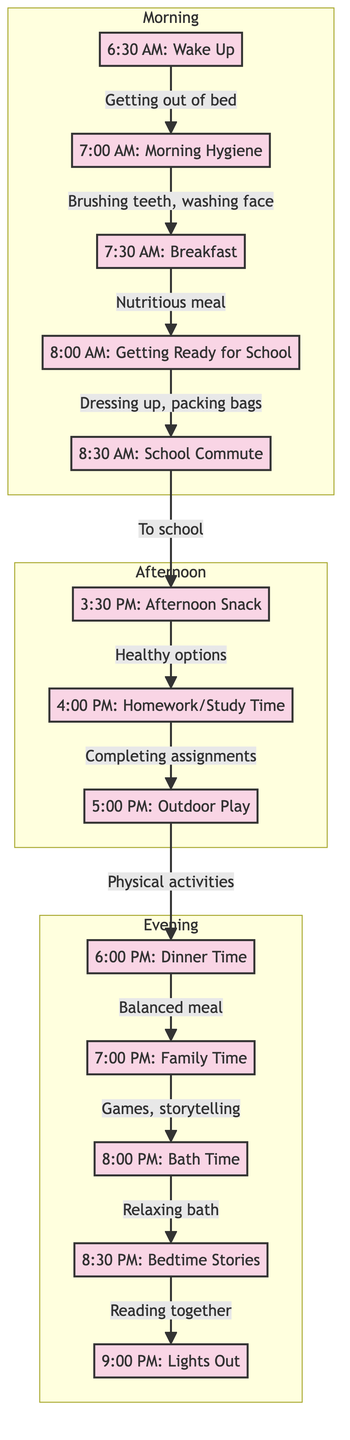What is the first activity of the day? The first activity shown at the bottom of the diagram is "Wake Up," which occurs at 6:30 AM.
Answer: Wake Up How many activities are listed in the evening section? The evening section contains five activities: Dinner Time, Family Time, Bath Time, Bedtime Stories, and Lights Out.
Answer: Five What follows Outdoor Play? After Outdoor Play, the next activity in the flow chart is Dinner Time.
Answer: Dinner Time Which activity occurs just before Bedtime Stories? The activity that precedes Bedtime Stories is Bath Time, which occurs at 8:00 PM.
Answer: Bath Time What is the time allocated for Homework/Study Time? Homework/Study Time is scheduled for 4:00 PM.
Answer: 4:00 PM Which activity happens directly after Breakfast? After Breakfast, the next activity in the sequence is Getting Ready for School.
Answer: Getting Ready for School How do you get from Family Time to Lights Out? To get to Lights Out from Family Time, the sequence follows Dinner Time to Family Time, then to Bath Time, followed by Bedtime Stories before reaching Lights Out.
Answer: Through Dinner Time, Bath Time, and Bedtime Stories What is the relationship between Getting Ready for School and the School Commute? The relationship is that Getting Ready for School leads directly to the School Commute, indicating that once kids are ready, they commute to school.
Answer: Directly leads to What is the last activity before bedtime? The last activity before bedtime is Lights Out, which marks the end of the daily routine.
Answer: Lights Out 